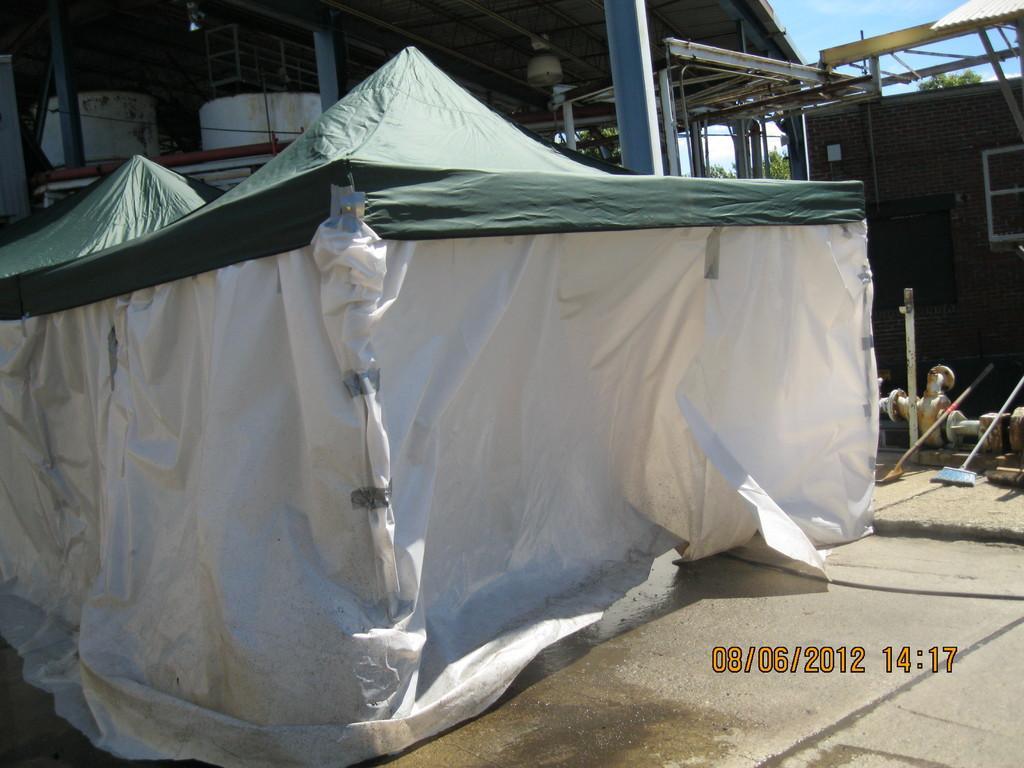How would you summarize this image in a sentence or two? In this image I can see the tent which is in white and green color. In the back I can see the shed and to the right there is a brick wall. In the back there are trees and the blue sky. 